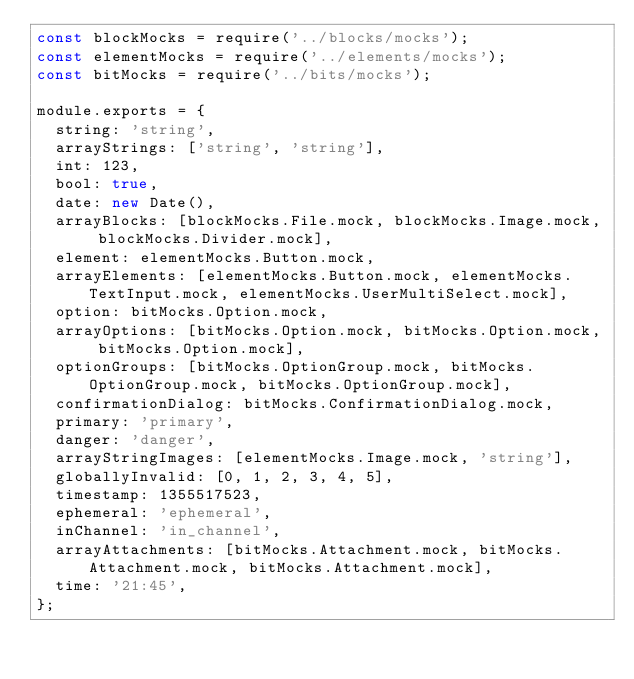Convert code to text. <code><loc_0><loc_0><loc_500><loc_500><_JavaScript_>const blockMocks = require('../blocks/mocks');
const elementMocks = require('../elements/mocks');
const bitMocks = require('../bits/mocks');

module.exports = {
  string: 'string',
  arrayStrings: ['string', 'string'],
  int: 123,
  bool: true,
  date: new Date(),
  arrayBlocks: [blockMocks.File.mock, blockMocks.Image.mock, blockMocks.Divider.mock],
  element: elementMocks.Button.mock,
  arrayElements: [elementMocks.Button.mock, elementMocks.TextInput.mock, elementMocks.UserMultiSelect.mock],
  option: bitMocks.Option.mock,
  arrayOptions: [bitMocks.Option.mock, bitMocks.Option.mock, bitMocks.Option.mock],
  optionGroups: [bitMocks.OptionGroup.mock, bitMocks.OptionGroup.mock, bitMocks.OptionGroup.mock],
  confirmationDialog: bitMocks.ConfirmationDialog.mock,
  primary: 'primary',
  danger: 'danger',
  arrayStringImages: [elementMocks.Image.mock, 'string'],
  globallyInvalid: [0, 1, 2, 3, 4, 5],
  timestamp: 1355517523,
  ephemeral: 'ephemeral',
  inChannel: 'in_channel',
  arrayAttachments: [bitMocks.Attachment.mock, bitMocks.Attachment.mock, bitMocks.Attachment.mock],
  time: '21:45',
};
</code> 